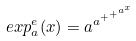Convert formula to latex. <formula><loc_0><loc_0><loc_500><loc_500>e x p _ { a } ^ { e } ( x ) = a ^ { a ^ { + ^ { + ^ { a ^ { x } } } } }</formula> 